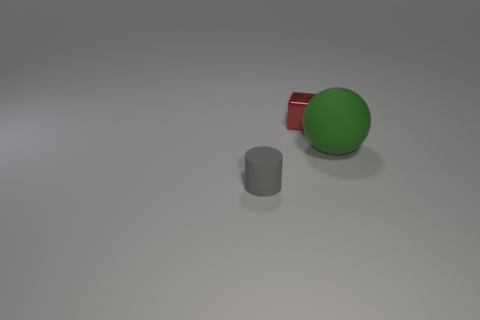Add 2 red metallic objects. How many objects exist? 5 Subtract all cubes. How many objects are left? 2 Subtract 1 red cubes. How many objects are left? 2 Subtract all brown balls. Subtract all gray blocks. How many balls are left? 1 Subtract all green matte cylinders. Subtract all matte balls. How many objects are left? 2 Add 3 tiny red cubes. How many tiny red cubes are left? 4 Add 2 small green matte spheres. How many small green matte spheres exist? 2 